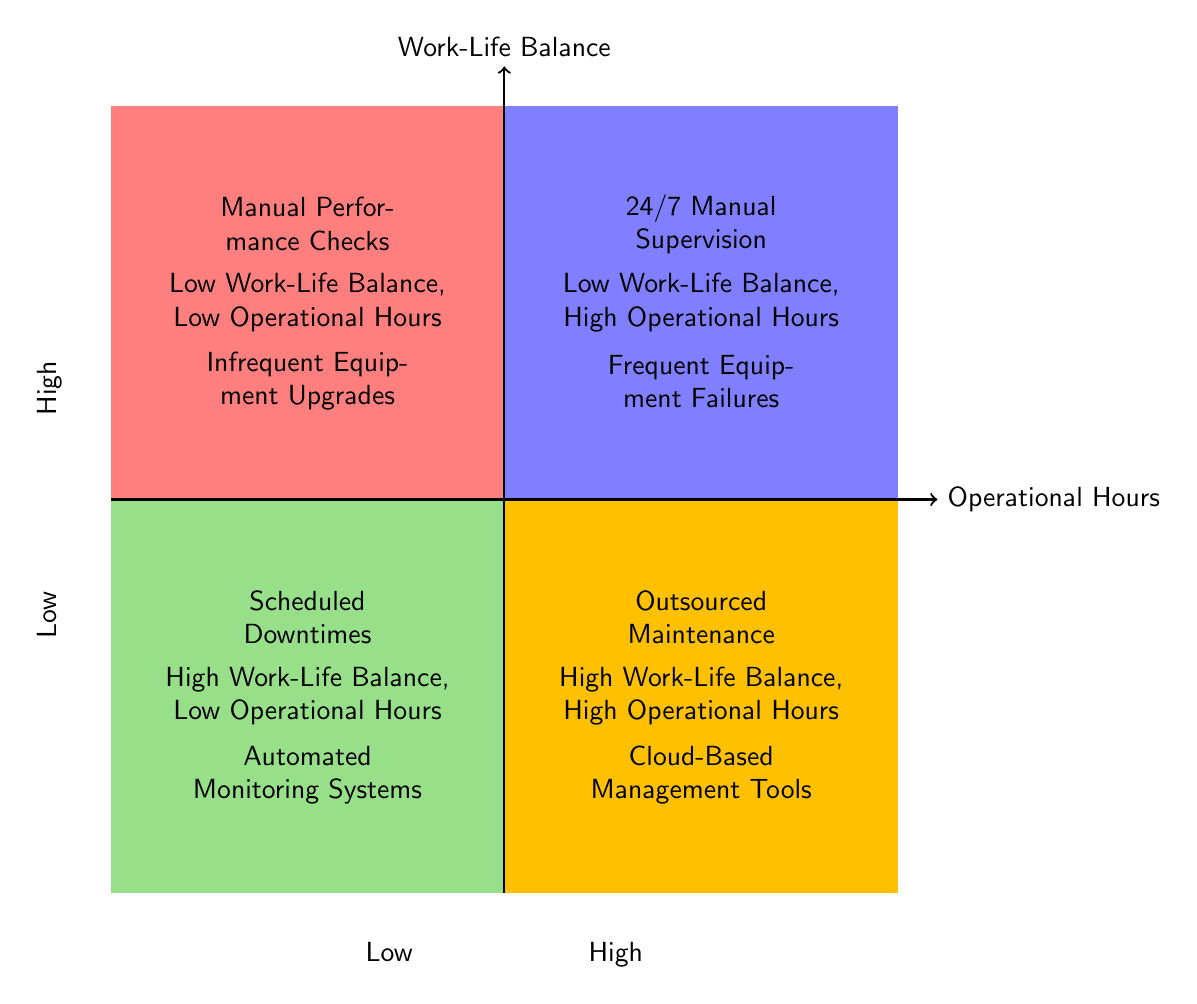What elements are found in the first quadrant? The first quadrant is located at the top-left of the diagram, which represents "Low Work-Life Balance, Low Operational Hours." The elements listed in this quadrant are "Manual Performance Checks" and "Infrequent Equipment Upgrades."
Answer: Manual Performance Checks, Infrequent Equipment Upgrades How many elements are in the second quadrant? The second quadrant is located at the top-right of the diagram, which represents "Low Work-Life Balance, High Operational Hours." There are two elements present: "24/7 Manual Supervision" and "Frequent Equipment Failures." Therefore, the count of elements is two.
Answer: 2 What is the relationship between high operational hours and outsourced maintenance? The element "Outsourced Maintenance" is located in the second quadrant, which signifies "Low Work-Life Balance, High Operational Hours." This indicates that if a high operational hour strategy is being employed, it is likely linked with outsourcing maintenance to manage work-life balance effectively despite the high hours.
Answer: High operational hours relate to outsourced maintenance Which quadrant includes automated monitoring systems? The element "Automated Monitoring Systems" is located in the bottom-left quadrant, which represents "High Work-Life Balance, Low Operational Hours." This indicates that using automated systems allows for better work-life balance while maintaining low operational hours.
Answer: High Work-Life Balance, Low Operational Hours What is the main characteristic of the third quadrant? The third quadrant, titled "Low Work-Life Balance, Low Operational Hours," indicates that the focus here is on a situation where neither work-life balance nor operational hours are maximized. This might suggest a lack of effort in either domain.
Answer: Low Work-Life Balance, Low Operational Hours Can you name one challenge associated with 24/7 manual supervision? The element "24/7 Manual Supervision" is found in the fourth quadrant, which represents "Low Work-Life Balance, High Operational Hours." A challenge associated with this approach would be the constant need for human oversight, which can lead to burnout and a lack of personal time.
Answer: Frequent Equipment Failures How does the presence of cloud-based management tools impact work-life balance? The element "Cloud-Based Management Tools" is present in the second quadrant, which signifies "High Work-Life Balance, High Operational Hours." This suggests that utilizing such tools can help maintain a good work-life balance even when operational hours are high.
Answer: Positive impact on work-life balance Which quadrant contains the element 'Scheduled Downtimes'? The element "Scheduled Downtimes" is located in the bottom-left quadrant labeled "High Work-Life Balance, Low Operational Hours." This implies a strategy to create balances in personal time while ensuring operational effectiveness.
Answer: High Work-Life Balance, Low Operational Hours 